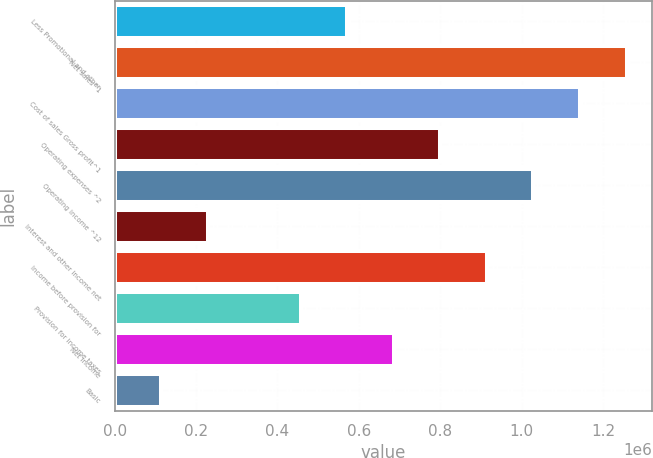Convert chart to OTSL. <chart><loc_0><loc_0><loc_500><loc_500><bar_chart><fcel>Less Promotional and other<fcel>Net sales^1<fcel>Cost of sales Gross profit^1<fcel>Operating expenses ^2<fcel>Operating income ^12<fcel>Interest and other income net<fcel>Income before provision for<fcel>Provision for income taxes<fcel>Net income<fcel>Basic<nl><fcel>571651<fcel>1.25763e+06<fcel>1.1433e+06<fcel>800310<fcel>1.02897e+06<fcel>228662<fcel>914640<fcel>457321<fcel>685980<fcel>114332<nl></chart> 